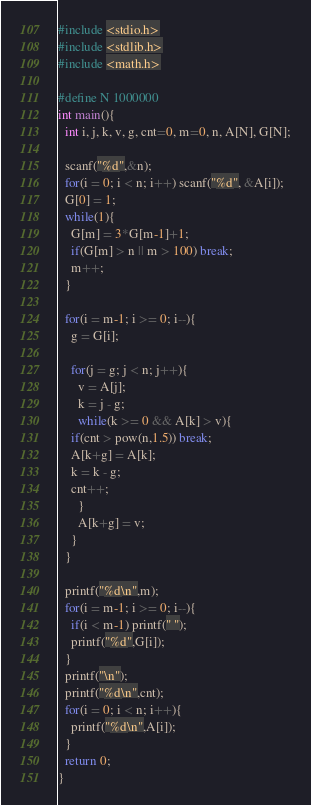Convert code to text. <code><loc_0><loc_0><loc_500><loc_500><_C_>#include <stdio.h>
#include <stdlib.h>
#include <math.h>

#define N 1000000
int main(){
  int i, j, k, v, g, cnt=0, m=0, n, A[N], G[N];

  scanf("%d",&n);
  for(i = 0; i < n; i++) scanf("%d", &A[i]);
  G[0] = 1;
  while(1){
    G[m] = 3*G[m-1]+1;
    if(G[m] > n || m > 100) break;
    m++;
  }

  for(i = m-1; i >= 0; i--){
    g = G[i];

    for(j = g; j < n; j++){
      v = A[j];
      k = j - g;
      while(k >= 0 && A[k] > v){
	if(cnt > pow(n,1.5)) break;
	A[k+g] = A[k];
	k = k - g;
	cnt++;
      }
      A[k+g] = v;
    }
  }
  
  printf("%d\n",m);
  for(i = m-1; i >= 0; i--){
    if(i < m-1) printf(" ");
    printf("%d",G[i]);
  }
  printf("\n");
  printf("%d\n",cnt);
  for(i = 0; i < n; i++){
    printf("%d\n",A[i]);
  }
  return 0;
}</code> 